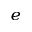Convert formula to latex. <formula><loc_0><loc_0><loc_500><loc_500>_ { e }</formula> 